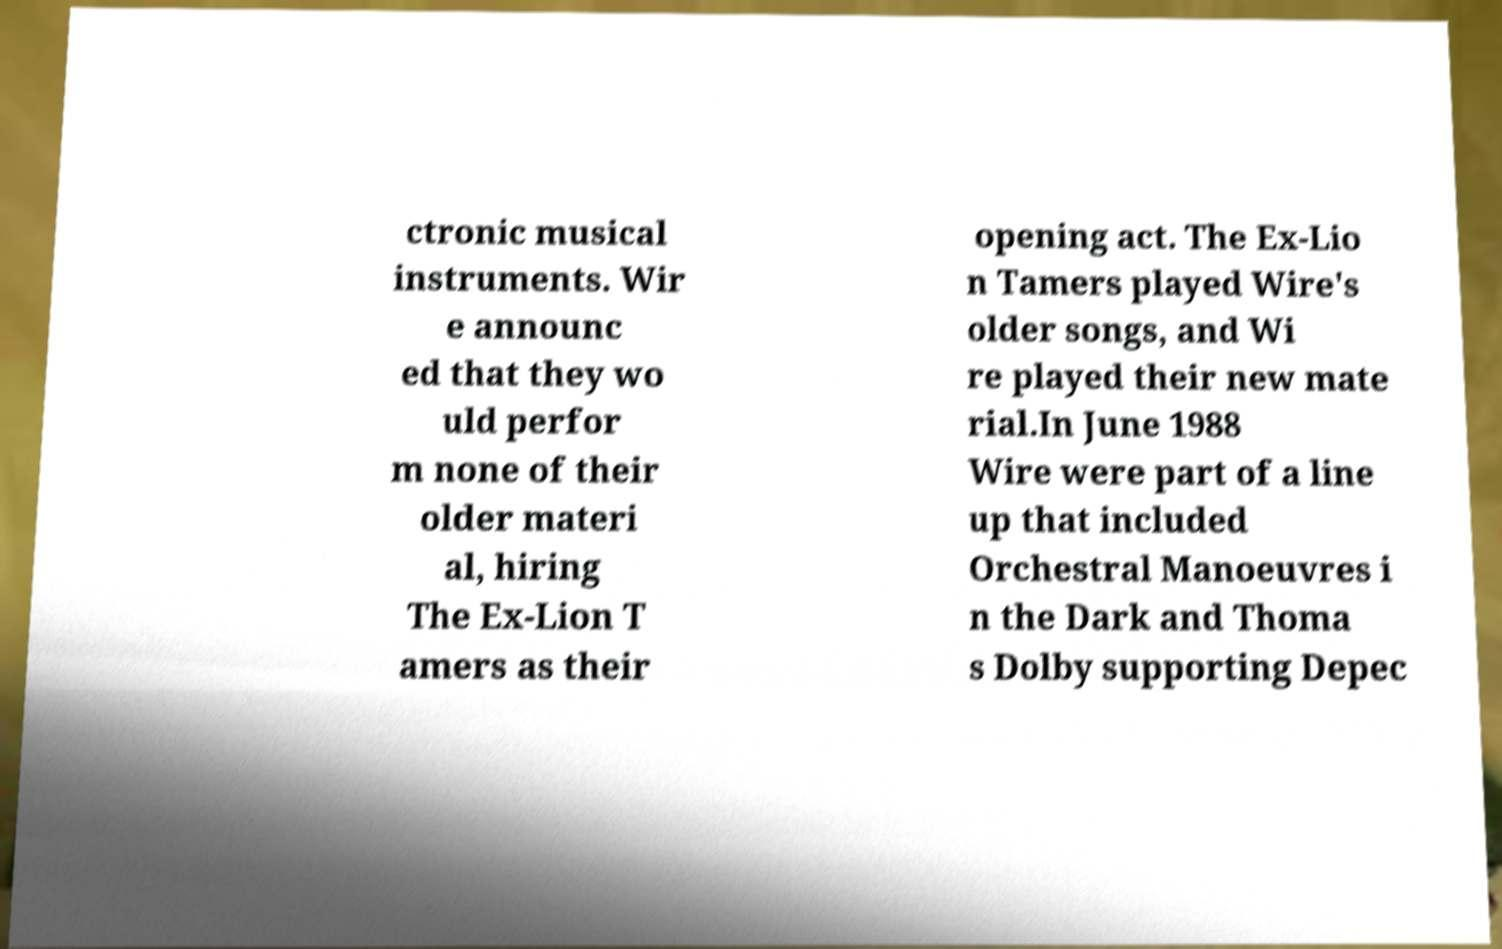Could you extract and type out the text from this image? ctronic musical instruments. Wir e announc ed that they wo uld perfor m none of their older materi al, hiring The Ex-Lion T amers as their opening act. The Ex-Lio n Tamers played Wire's older songs, and Wi re played their new mate rial.In June 1988 Wire were part of a line up that included Orchestral Manoeuvres i n the Dark and Thoma s Dolby supporting Depec 